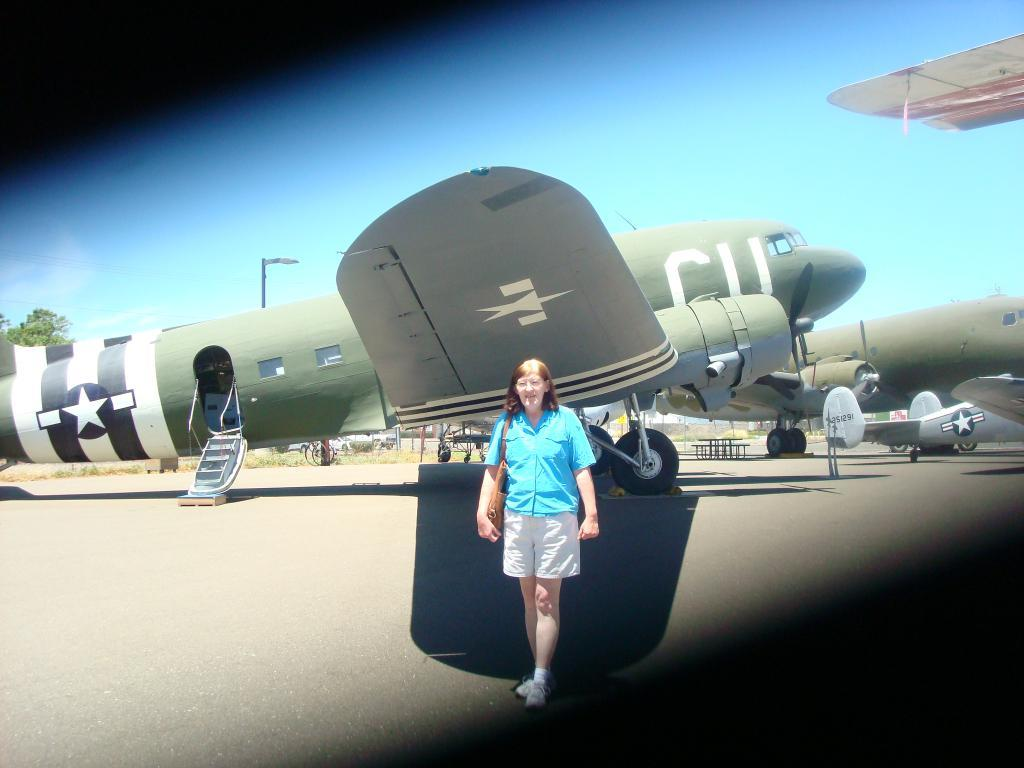<image>
Relay a brief, clear account of the picture shown. Person standing in front of an airplane that says CU . 